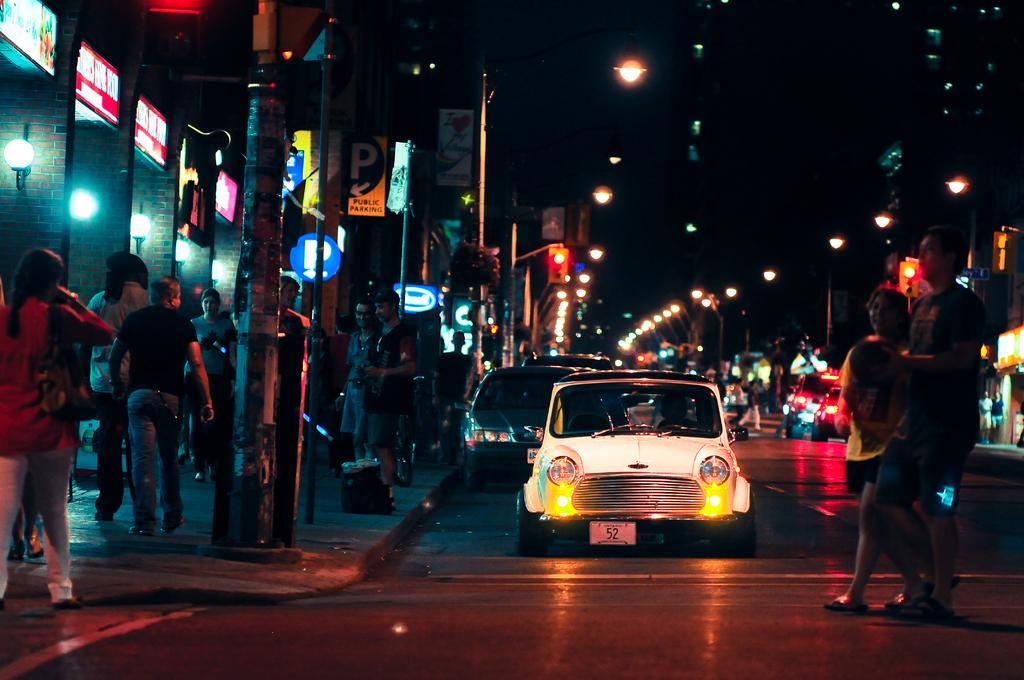What can be seen on the road in the image? There are vehicles on the road in the image. Who or what else is present in the image? There is a group of people in the image. What can be seen illuminating the scene in the image? There are lights visible in the image. What type of structures are present in the image? There are boards and buildings in the image. What other objects can be seen in the image? There are poles in the image. What time of day is it in the image, given the presence of morning light? The provided facts do not mention anything about morning light or the time of day. The image only shows lights, which could be present at any time of day or night. What type of coil is being used by the group of people in the image? There is no coil present in the image. 